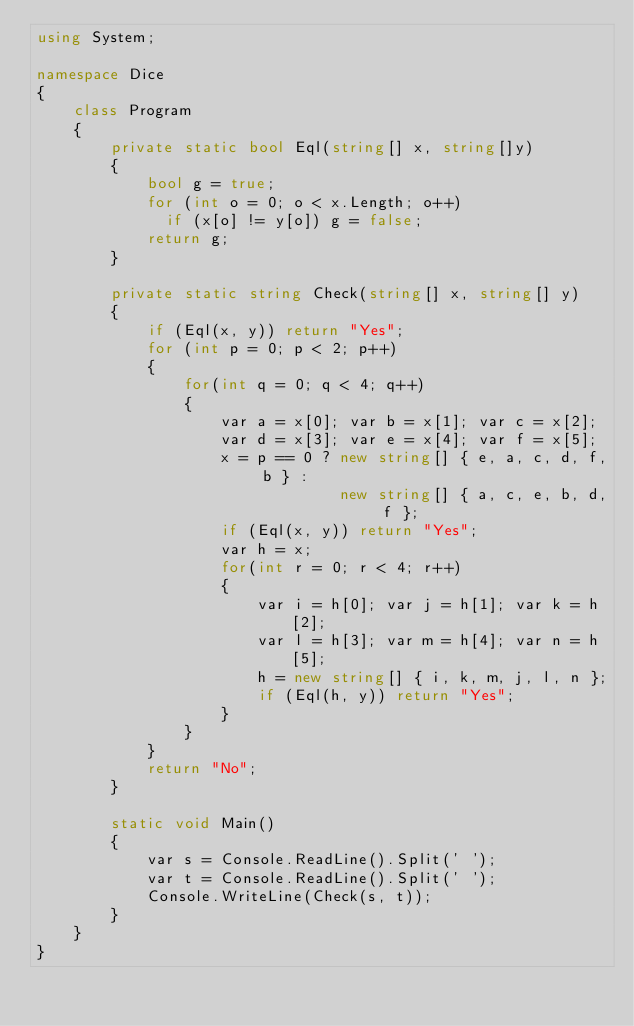Convert code to text. <code><loc_0><loc_0><loc_500><loc_500><_C#_>using System;

namespace Dice
{
    class Program
    {
        private static bool Eql(string[] x, string[]y)
        {
            bool g = true;
            for (int o = 0; o < x.Length; o++)
              if (x[o] != y[o]) g = false;
            return g;
        }

        private static string Check(string[] x, string[] y)
        {
            if (Eql(x, y)) return "Yes";
            for (int p = 0; p < 2; p++)
            {
                for(int q = 0; q < 4; q++)
                {
                    var a = x[0]; var b = x[1]; var c = x[2];
                    var d = x[3]; var e = x[4]; var f = x[5];
                    x = p == 0 ? new string[] { e, a, c, d, f, b } :
                                 new string[] { a, c, e, b, d, f };
                    if (Eql(x, y)) return "Yes";
                    var h = x;
                    for(int r = 0; r < 4; r++)
                    {
                        var i = h[0]; var j = h[1]; var k = h[2];
                        var l = h[3]; var m = h[4]; var n = h[5];
                        h = new string[] { i, k, m, j, l, n };
                        if (Eql(h, y)) return "Yes";
                    }
                }
            }
            return "No";
        }

        static void Main()
        {
            var s = Console.ReadLine().Split(' ');
            var t = Console.ReadLine().Split(' ');
            Console.WriteLine(Check(s, t));
        }
    }
}</code> 